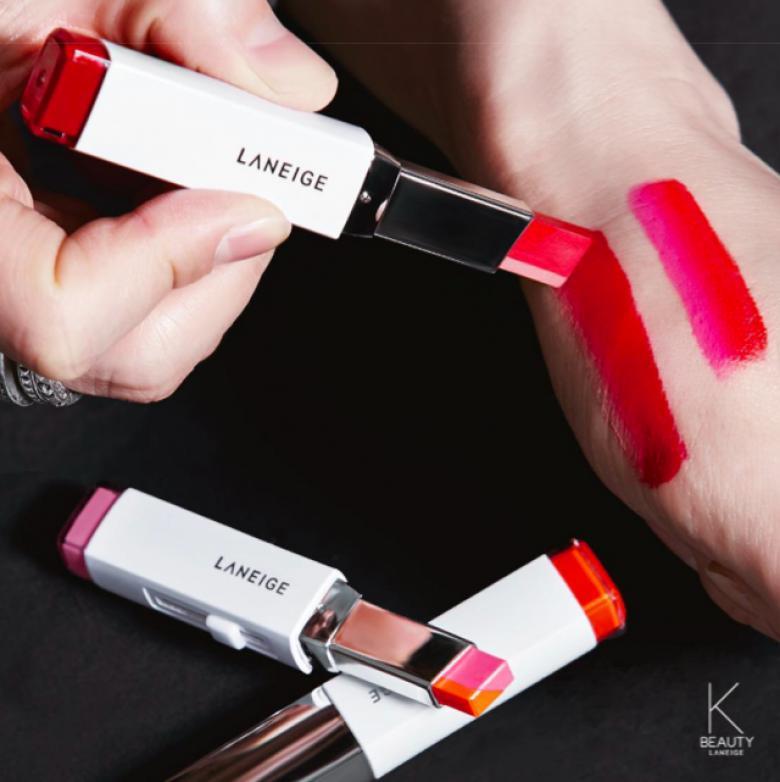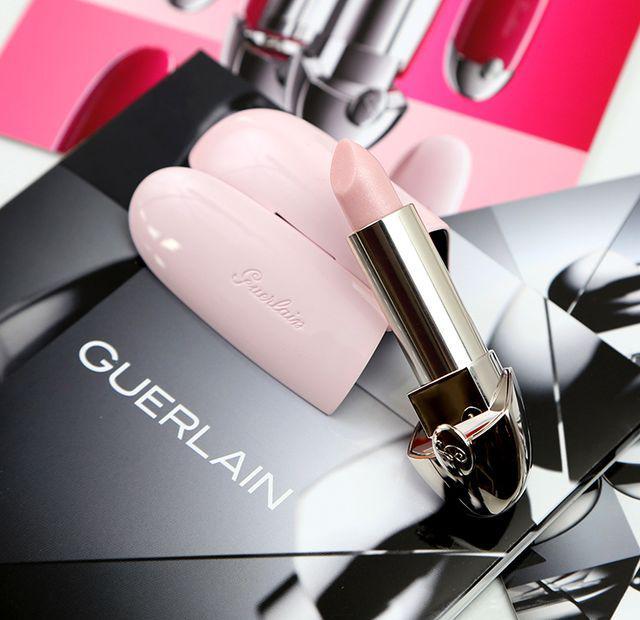The first image is the image on the left, the second image is the image on the right. Assess this claim about the two images: "A human hand is holding a lipstick without a cap.". Correct or not? Answer yes or no. Yes. The first image is the image on the left, the second image is the image on the right. Examine the images to the left and right. Is the description "An image shows a hand holding an opened lipstick." accurate? Answer yes or no. Yes. 